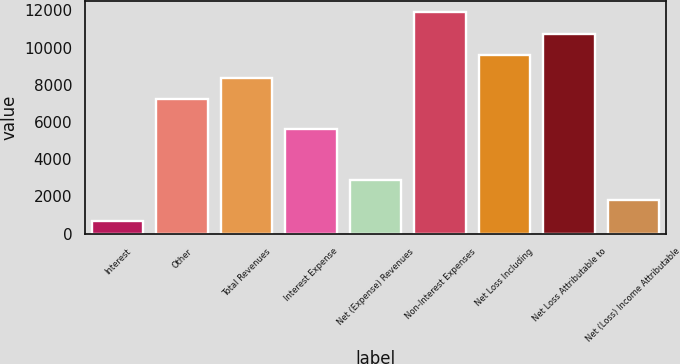<chart> <loc_0><loc_0><loc_500><loc_500><bar_chart><fcel>Interest<fcel>Other<fcel>Total Revenues<fcel>Interest Expense<fcel>Net (Expense) Revenues<fcel>Non-Interest Expenses<fcel>Net Loss Including<fcel>Net Loss Attributable to<fcel>Net (Loss) Income Attributable<nl><fcel>657<fcel>7229<fcel>8353.3<fcel>5604<fcel>2905.6<fcel>11900<fcel>9618<fcel>10742.3<fcel>1781.3<nl></chart> 